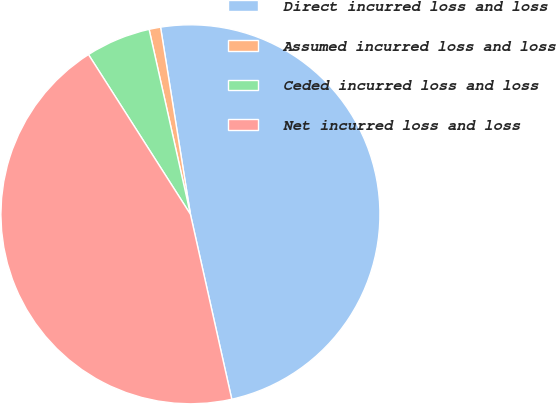<chart> <loc_0><loc_0><loc_500><loc_500><pie_chart><fcel>Direct incurred loss and loss<fcel>Assumed incurred loss and loss<fcel>Ceded incurred loss and loss<fcel>Net incurred loss and loss<nl><fcel>49.02%<fcel>0.98%<fcel>5.54%<fcel>44.46%<nl></chart> 